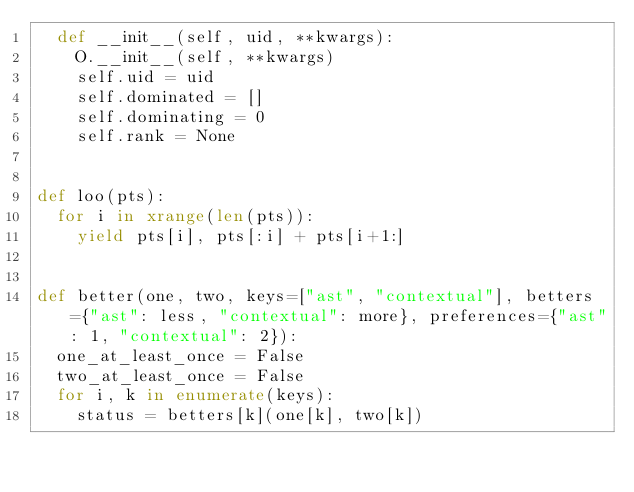<code> <loc_0><loc_0><loc_500><loc_500><_Python_>  def __init__(self, uid, **kwargs):
    O.__init__(self, **kwargs)
    self.uid = uid
    self.dominated = []
    self.dominating = 0
    self.rank = None


def loo(pts):
  for i in xrange(len(pts)):
    yield pts[i], pts[:i] + pts[i+1:]


def better(one, two, keys=["ast", "contextual"], betters={"ast": less, "contextual": more}, preferences={"ast": 1, "contextual": 2}):
  one_at_least_once = False
  two_at_least_once = False
  for i, k in enumerate(keys):
    status = betters[k](one[k], two[k])</code> 